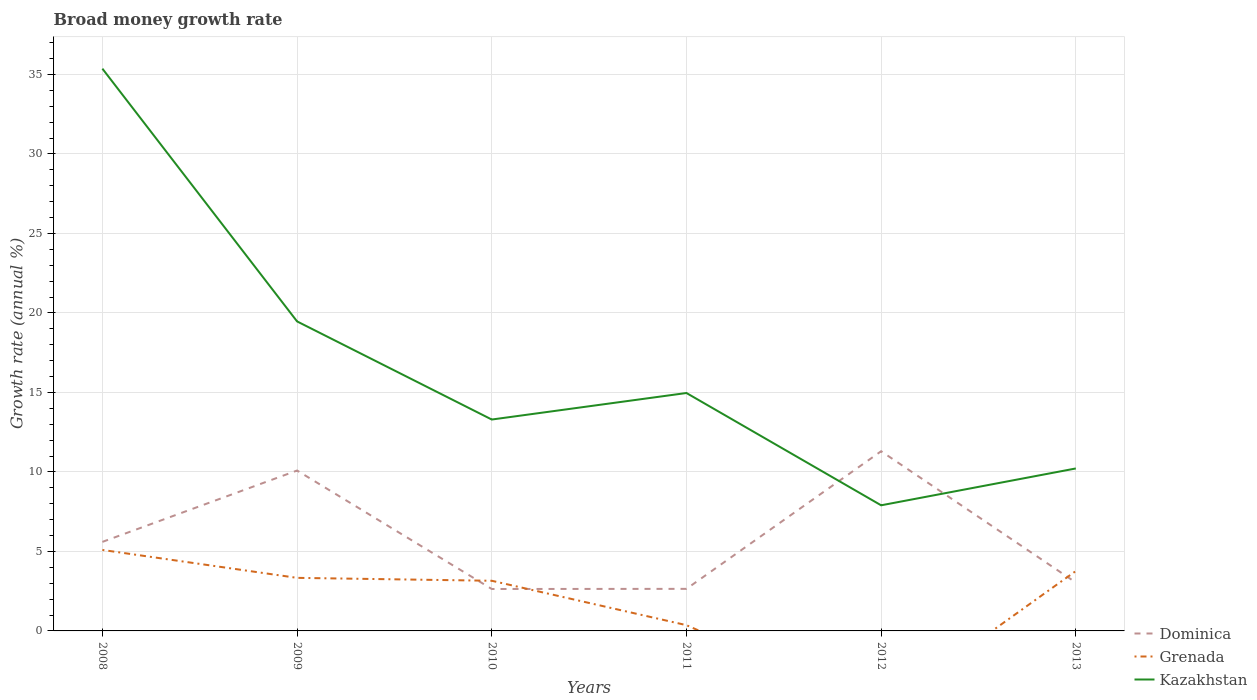Is the number of lines equal to the number of legend labels?
Provide a succinct answer. No. Across all years, what is the maximum growth rate in Dominica?
Give a very brief answer. 2.64. What is the total growth rate in Dominica in the graph?
Offer a very short reply. -0.01. What is the difference between the highest and the second highest growth rate in Grenada?
Offer a very short reply. 5.09. How many lines are there?
Offer a terse response. 3. What is the difference between two consecutive major ticks on the Y-axis?
Your response must be concise. 5. Where does the legend appear in the graph?
Your response must be concise. Bottom right. How many legend labels are there?
Provide a succinct answer. 3. What is the title of the graph?
Offer a very short reply. Broad money growth rate. What is the label or title of the Y-axis?
Keep it short and to the point. Growth rate (annual %). What is the Growth rate (annual %) of Dominica in 2008?
Give a very brief answer. 5.6. What is the Growth rate (annual %) of Grenada in 2008?
Offer a terse response. 5.09. What is the Growth rate (annual %) of Kazakhstan in 2008?
Make the answer very short. 35.37. What is the Growth rate (annual %) of Dominica in 2009?
Your response must be concise. 10.09. What is the Growth rate (annual %) of Grenada in 2009?
Offer a terse response. 3.34. What is the Growth rate (annual %) in Kazakhstan in 2009?
Give a very brief answer. 19.47. What is the Growth rate (annual %) in Dominica in 2010?
Your answer should be very brief. 2.64. What is the Growth rate (annual %) of Grenada in 2010?
Make the answer very short. 3.15. What is the Growth rate (annual %) of Kazakhstan in 2010?
Offer a terse response. 13.3. What is the Growth rate (annual %) of Dominica in 2011?
Your answer should be compact. 2.65. What is the Growth rate (annual %) of Grenada in 2011?
Offer a terse response. 0.36. What is the Growth rate (annual %) of Kazakhstan in 2011?
Keep it short and to the point. 14.96. What is the Growth rate (annual %) in Dominica in 2012?
Make the answer very short. 11.3. What is the Growth rate (annual %) of Kazakhstan in 2012?
Ensure brevity in your answer.  7.9. What is the Growth rate (annual %) in Dominica in 2013?
Offer a terse response. 3.04. What is the Growth rate (annual %) of Grenada in 2013?
Provide a short and direct response. 3.77. What is the Growth rate (annual %) in Kazakhstan in 2013?
Your answer should be very brief. 10.22. Across all years, what is the maximum Growth rate (annual %) of Dominica?
Your answer should be compact. 11.3. Across all years, what is the maximum Growth rate (annual %) in Grenada?
Your response must be concise. 5.09. Across all years, what is the maximum Growth rate (annual %) in Kazakhstan?
Ensure brevity in your answer.  35.37. Across all years, what is the minimum Growth rate (annual %) of Dominica?
Keep it short and to the point. 2.64. Across all years, what is the minimum Growth rate (annual %) in Kazakhstan?
Your answer should be compact. 7.9. What is the total Growth rate (annual %) in Dominica in the graph?
Provide a succinct answer. 35.32. What is the total Growth rate (annual %) of Grenada in the graph?
Provide a short and direct response. 15.71. What is the total Growth rate (annual %) of Kazakhstan in the graph?
Your response must be concise. 101.21. What is the difference between the Growth rate (annual %) in Dominica in 2008 and that in 2009?
Keep it short and to the point. -4.49. What is the difference between the Growth rate (annual %) of Grenada in 2008 and that in 2009?
Your answer should be compact. 1.76. What is the difference between the Growth rate (annual %) in Kazakhstan in 2008 and that in 2009?
Give a very brief answer. 15.9. What is the difference between the Growth rate (annual %) in Dominica in 2008 and that in 2010?
Provide a short and direct response. 2.96. What is the difference between the Growth rate (annual %) in Grenada in 2008 and that in 2010?
Give a very brief answer. 1.94. What is the difference between the Growth rate (annual %) of Kazakhstan in 2008 and that in 2010?
Offer a terse response. 22.07. What is the difference between the Growth rate (annual %) of Dominica in 2008 and that in 2011?
Your answer should be very brief. 2.95. What is the difference between the Growth rate (annual %) in Grenada in 2008 and that in 2011?
Keep it short and to the point. 4.73. What is the difference between the Growth rate (annual %) of Kazakhstan in 2008 and that in 2011?
Your answer should be compact. 20.4. What is the difference between the Growth rate (annual %) of Dominica in 2008 and that in 2012?
Offer a very short reply. -5.7. What is the difference between the Growth rate (annual %) in Kazakhstan in 2008 and that in 2012?
Offer a very short reply. 27.46. What is the difference between the Growth rate (annual %) in Dominica in 2008 and that in 2013?
Provide a short and direct response. 2.56. What is the difference between the Growth rate (annual %) of Grenada in 2008 and that in 2013?
Provide a succinct answer. 1.33. What is the difference between the Growth rate (annual %) in Kazakhstan in 2008 and that in 2013?
Offer a very short reply. 25.15. What is the difference between the Growth rate (annual %) of Dominica in 2009 and that in 2010?
Give a very brief answer. 7.45. What is the difference between the Growth rate (annual %) in Grenada in 2009 and that in 2010?
Ensure brevity in your answer.  0.18. What is the difference between the Growth rate (annual %) of Kazakhstan in 2009 and that in 2010?
Offer a terse response. 6.17. What is the difference between the Growth rate (annual %) of Dominica in 2009 and that in 2011?
Provide a succinct answer. 7.44. What is the difference between the Growth rate (annual %) of Grenada in 2009 and that in 2011?
Offer a terse response. 2.98. What is the difference between the Growth rate (annual %) in Kazakhstan in 2009 and that in 2011?
Make the answer very short. 4.5. What is the difference between the Growth rate (annual %) of Dominica in 2009 and that in 2012?
Give a very brief answer. -1.21. What is the difference between the Growth rate (annual %) of Kazakhstan in 2009 and that in 2012?
Your response must be concise. 11.57. What is the difference between the Growth rate (annual %) in Dominica in 2009 and that in 2013?
Give a very brief answer. 7.05. What is the difference between the Growth rate (annual %) in Grenada in 2009 and that in 2013?
Your answer should be compact. -0.43. What is the difference between the Growth rate (annual %) in Kazakhstan in 2009 and that in 2013?
Make the answer very short. 9.25. What is the difference between the Growth rate (annual %) in Dominica in 2010 and that in 2011?
Your answer should be very brief. -0.01. What is the difference between the Growth rate (annual %) in Grenada in 2010 and that in 2011?
Provide a short and direct response. 2.79. What is the difference between the Growth rate (annual %) of Kazakhstan in 2010 and that in 2011?
Your answer should be compact. -1.67. What is the difference between the Growth rate (annual %) of Dominica in 2010 and that in 2012?
Offer a terse response. -8.66. What is the difference between the Growth rate (annual %) in Kazakhstan in 2010 and that in 2012?
Provide a short and direct response. 5.39. What is the difference between the Growth rate (annual %) of Dominica in 2010 and that in 2013?
Offer a very short reply. -0.41. What is the difference between the Growth rate (annual %) in Grenada in 2010 and that in 2013?
Provide a short and direct response. -0.61. What is the difference between the Growth rate (annual %) in Kazakhstan in 2010 and that in 2013?
Your answer should be compact. 3.08. What is the difference between the Growth rate (annual %) in Dominica in 2011 and that in 2012?
Your answer should be compact. -8.66. What is the difference between the Growth rate (annual %) in Kazakhstan in 2011 and that in 2012?
Make the answer very short. 7.06. What is the difference between the Growth rate (annual %) in Dominica in 2011 and that in 2013?
Offer a very short reply. -0.4. What is the difference between the Growth rate (annual %) in Grenada in 2011 and that in 2013?
Ensure brevity in your answer.  -3.4. What is the difference between the Growth rate (annual %) in Kazakhstan in 2011 and that in 2013?
Give a very brief answer. 4.75. What is the difference between the Growth rate (annual %) in Dominica in 2012 and that in 2013?
Give a very brief answer. 8.26. What is the difference between the Growth rate (annual %) in Kazakhstan in 2012 and that in 2013?
Offer a very short reply. -2.32. What is the difference between the Growth rate (annual %) in Dominica in 2008 and the Growth rate (annual %) in Grenada in 2009?
Make the answer very short. 2.26. What is the difference between the Growth rate (annual %) of Dominica in 2008 and the Growth rate (annual %) of Kazakhstan in 2009?
Offer a terse response. -13.87. What is the difference between the Growth rate (annual %) in Grenada in 2008 and the Growth rate (annual %) in Kazakhstan in 2009?
Provide a succinct answer. -14.37. What is the difference between the Growth rate (annual %) of Dominica in 2008 and the Growth rate (annual %) of Grenada in 2010?
Give a very brief answer. 2.45. What is the difference between the Growth rate (annual %) in Dominica in 2008 and the Growth rate (annual %) in Kazakhstan in 2010?
Provide a succinct answer. -7.7. What is the difference between the Growth rate (annual %) of Grenada in 2008 and the Growth rate (annual %) of Kazakhstan in 2010?
Give a very brief answer. -8.2. What is the difference between the Growth rate (annual %) in Dominica in 2008 and the Growth rate (annual %) in Grenada in 2011?
Your answer should be compact. 5.24. What is the difference between the Growth rate (annual %) of Dominica in 2008 and the Growth rate (annual %) of Kazakhstan in 2011?
Ensure brevity in your answer.  -9.36. What is the difference between the Growth rate (annual %) of Grenada in 2008 and the Growth rate (annual %) of Kazakhstan in 2011?
Offer a very short reply. -9.87. What is the difference between the Growth rate (annual %) in Dominica in 2008 and the Growth rate (annual %) in Kazakhstan in 2012?
Keep it short and to the point. -2.3. What is the difference between the Growth rate (annual %) in Grenada in 2008 and the Growth rate (annual %) in Kazakhstan in 2012?
Offer a very short reply. -2.81. What is the difference between the Growth rate (annual %) of Dominica in 2008 and the Growth rate (annual %) of Grenada in 2013?
Give a very brief answer. 1.83. What is the difference between the Growth rate (annual %) in Dominica in 2008 and the Growth rate (annual %) in Kazakhstan in 2013?
Keep it short and to the point. -4.62. What is the difference between the Growth rate (annual %) of Grenada in 2008 and the Growth rate (annual %) of Kazakhstan in 2013?
Provide a short and direct response. -5.13. What is the difference between the Growth rate (annual %) of Dominica in 2009 and the Growth rate (annual %) of Grenada in 2010?
Your answer should be very brief. 6.93. What is the difference between the Growth rate (annual %) in Dominica in 2009 and the Growth rate (annual %) in Kazakhstan in 2010?
Your answer should be very brief. -3.21. What is the difference between the Growth rate (annual %) of Grenada in 2009 and the Growth rate (annual %) of Kazakhstan in 2010?
Your response must be concise. -9.96. What is the difference between the Growth rate (annual %) of Dominica in 2009 and the Growth rate (annual %) of Grenada in 2011?
Keep it short and to the point. 9.73. What is the difference between the Growth rate (annual %) of Dominica in 2009 and the Growth rate (annual %) of Kazakhstan in 2011?
Offer a very short reply. -4.88. What is the difference between the Growth rate (annual %) of Grenada in 2009 and the Growth rate (annual %) of Kazakhstan in 2011?
Provide a succinct answer. -11.63. What is the difference between the Growth rate (annual %) of Dominica in 2009 and the Growth rate (annual %) of Kazakhstan in 2012?
Provide a succinct answer. 2.19. What is the difference between the Growth rate (annual %) of Grenada in 2009 and the Growth rate (annual %) of Kazakhstan in 2012?
Provide a short and direct response. -4.56. What is the difference between the Growth rate (annual %) in Dominica in 2009 and the Growth rate (annual %) in Grenada in 2013?
Your answer should be very brief. 6.32. What is the difference between the Growth rate (annual %) of Dominica in 2009 and the Growth rate (annual %) of Kazakhstan in 2013?
Your answer should be compact. -0.13. What is the difference between the Growth rate (annual %) in Grenada in 2009 and the Growth rate (annual %) in Kazakhstan in 2013?
Your answer should be compact. -6.88. What is the difference between the Growth rate (annual %) in Dominica in 2010 and the Growth rate (annual %) in Grenada in 2011?
Give a very brief answer. 2.28. What is the difference between the Growth rate (annual %) of Dominica in 2010 and the Growth rate (annual %) of Kazakhstan in 2011?
Give a very brief answer. -12.33. What is the difference between the Growth rate (annual %) of Grenada in 2010 and the Growth rate (annual %) of Kazakhstan in 2011?
Keep it short and to the point. -11.81. What is the difference between the Growth rate (annual %) of Dominica in 2010 and the Growth rate (annual %) of Kazakhstan in 2012?
Your answer should be compact. -5.26. What is the difference between the Growth rate (annual %) in Grenada in 2010 and the Growth rate (annual %) in Kazakhstan in 2012?
Make the answer very short. -4.75. What is the difference between the Growth rate (annual %) of Dominica in 2010 and the Growth rate (annual %) of Grenada in 2013?
Offer a very short reply. -1.13. What is the difference between the Growth rate (annual %) in Dominica in 2010 and the Growth rate (annual %) in Kazakhstan in 2013?
Offer a terse response. -7.58. What is the difference between the Growth rate (annual %) of Grenada in 2010 and the Growth rate (annual %) of Kazakhstan in 2013?
Offer a very short reply. -7.06. What is the difference between the Growth rate (annual %) of Dominica in 2011 and the Growth rate (annual %) of Kazakhstan in 2012?
Your answer should be very brief. -5.26. What is the difference between the Growth rate (annual %) of Grenada in 2011 and the Growth rate (annual %) of Kazakhstan in 2012?
Offer a very short reply. -7.54. What is the difference between the Growth rate (annual %) of Dominica in 2011 and the Growth rate (annual %) of Grenada in 2013?
Your answer should be very brief. -1.12. What is the difference between the Growth rate (annual %) in Dominica in 2011 and the Growth rate (annual %) in Kazakhstan in 2013?
Provide a short and direct response. -7.57. What is the difference between the Growth rate (annual %) in Grenada in 2011 and the Growth rate (annual %) in Kazakhstan in 2013?
Offer a very short reply. -9.86. What is the difference between the Growth rate (annual %) of Dominica in 2012 and the Growth rate (annual %) of Grenada in 2013?
Keep it short and to the point. 7.54. What is the difference between the Growth rate (annual %) in Dominica in 2012 and the Growth rate (annual %) in Kazakhstan in 2013?
Make the answer very short. 1.08. What is the average Growth rate (annual %) in Dominica per year?
Offer a terse response. 5.89. What is the average Growth rate (annual %) of Grenada per year?
Your answer should be very brief. 2.62. What is the average Growth rate (annual %) in Kazakhstan per year?
Give a very brief answer. 16.87. In the year 2008, what is the difference between the Growth rate (annual %) in Dominica and Growth rate (annual %) in Grenada?
Offer a very short reply. 0.51. In the year 2008, what is the difference between the Growth rate (annual %) of Dominica and Growth rate (annual %) of Kazakhstan?
Provide a succinct answer. -29.77. In the year 2008, what is the difference between the Growth rate (annual %) of Grenada and Growth rate (annual %) of Kazakhstan?
Give a very brief answer. -30.27. In the year 2009, what is the difference between the Growth rate (annual %) in Dominica and Growth rate (annual %) in Grenada?
Your answer should be compact. 6.75. In the year 2009, what is the difference between the Growth rate (annual %) of Dominica and Growth rate (annual %) of Kazakhstan?
Give a very brief answer. -9.38. In the year 2009, what is the difference between the Growth rate (annual %) of Grenada and Growth rate (annual %) of Kazakhstan?
Provide a succinct answer. -16.13. In the year 2010, what is the difference between the Growth rate (annual %) of Dominica and Growth rate (annual %) of Grenada?
Give a very brief answer. -0.52. In the year 2010, what is the difference between the Growth rate (annual %) in Dominica and Growth rate (annual %) in Kazakhstan?
Offer a terse response. -10.66. In the year 2010, what is the difference between the Growth rate (annual %) of Grenada and Growth rate (annual %) of Kazakhstan?
Make the answer very short. -10.14. In the year 2011, what is the difference between the Growth rate (annual %) of Dominica and Growth rate (annual %) of Grenada?
Ensure brevity in your answer.  2.28. In the year 2011, what is the difference between the Growth rate (annual %) of Dominica and Growth rate (annual %) of Kazakhstan?
Offer a very short reply. -12.32. In the year 2011, what is the difference between the Growth rate (annual %) of Grenada and Growth rate (annual %) of Kazakhstan?
Your answer should be very brief. -14.6. In the year 2012, what is the difference between the Growth rate (annual %) of Dominica and Growth rate (annual %) of Kazakhstan?
Ensure brevity in your answer.  3.4. In the year 2013, what is the difference between the Growth rate (annual %) in Dominica and Growth rate (annual %) in Grenada?
Your response must be concise. -0.72. In the year 2013, what is the difference between the Growth rate (annual %) of Dominica and Growth rate (annual %) of Kazakhstan?
Your response must be concise. -7.18. In the year 2013, what is the difference between the Growth rate (annual %) of Grenada and Growth rate (annual %) of Kazakhstan?
Give a very brief answer. -6.45. What is the ratio of the Growth rate (annual %) in Dominica in 2008 to that in 2009?
Keep it short and to the point. 0.56. What is the ratio of the Growth rate (annual %) of Grenada in 2008 to that in 2009?
Your answer should be very brief. 1.53. What is the ratio of the Growth rate (annual %) of Kazakhstan in 2008 to that in 2009?
Ensure brevity in your answer.  1.82. What is the ratio of the Growth rate (annual %) in Dominica in 2008 to that in 2010?
Provide a succinct answer. 2.12. What is the ratio of the Growth rate (annual %) in Grenada in 2008 to that in 2010?
Keep it short and to the point. 1.61. What is the ratio of the Growth rate (annual %) in Kazakhstan in 2008 to that in 2010?
Your response must be concise. 2.66. What is the ratio of the Growth rate (annual %) in Dominica in 2008 to that in 2011?
Offer a very short reply. 2.12. What is the ratio of the Growth rate (annual %) in Grenada in 2008 to that in 2011?
Provide a succinct answer. 14.07. What is the ratio of the Growth rate (annual %) in Kazakhstan in 2008 to that in 2011?
Make the answer very short. 2.36. What is the ratio of the Growth rate (annual %) in Dominica in 2008 to that in 2012?
Ensure brevity in your answer.  0.5. What is the ratio of the Growth rate (annual %) in Kazakhstan in 2008 to that in 2012?
Your response must be concise. 4.48. What is the ratio of the Growth rate (annual %) of Dominica in 2008 to that in 2013?
Your answer should be compact. 1.84. What is the ratio of the Growth rate (annual %) of Grenada in 2008 to that in 2013?
Your answer should be compact. 1.35. What is the ratio of the Growth rate (annual %) in Kazakhstan in 2008 to that in 2013?
Ensure brevity in your answer.  3.46. What is the ratio of the Growth rate (annual %) in Dominica in 2009 to that in 2010?
Offer a very short reply. 3.83. What is the ratio of the Growth rate (annual %) of Grenada in 2009 to that in 2010?
Your answer should be very brief. 1.06. What is the ratio of the Growth rate (annual %) of Kazakhstan in 2009 to that in 2010?
Make the answer very short. 1.46. What is the ratio of the Growth rate (annual %) in Dominica in 2009 to that in 2011?
Provide a short and direct response. 3.81. What is the ratio of the Growth rate (annual %) of Grenada in 2009 to that in 2011?
Your answer should be very brief. 9.22. What is the ratio of the Growth rate (annual %) in Kazakhstan in 2009 to that in 2011?
Give a very brief answer. 1.3. What is the ratio of the Growth rate (annual %) in Dominica in 2009 to that in 2012?
Keep it short and to the point. 0.89. What is the ratio of the Growth rate (annual %) in Kazakhstan in 2009 to that in 2012?
Your answer should be very brief. 2.46. What is the ratio of the Growth rate (annual %) in Dominica in 2009 to that in 2013?
Offer a very short reply. 3.32. What is the ratio of the Growth rate (annual %) in Grenada in 2009 to that in 2013?
Your answer should be compact. 0.89. What is the ratio of the Growth rate (annual %) in Kazakhstan in 2009 to that in 2013?
Your answer should be compact. 1.91. What is the ratio of the Growth rate (annual %) in Dominica in 2010 to that in 2011?
Ensure brevity in your answer.  1. What is the ratio of the Growth rate (annual %) in Grenada in 2010 to that in 2011?
Give a very brief answer. 8.72. What is the ratio of the Growth rate (annual %) of Kazakhstan in 2010 to that in 2011?
Offer a terse response. 0.89. What is the ratio of the Growth rate (annual %) of Dominica in 2010 to that in 2012?
Offer a very short reply. 0.23. What is the ratio of the Growth rate (annual %) of Kazakhstan in 2010 to that in 2012?
Provide a succinct answer. 1.68. What is the ratio of the Growth rate (annual %) in Dominica in 2010 to that in 2013?
Offer a very short reply. 0.87. What is the ratio of the Growth rate (annual %) in Grenada in 2010 to that in 2013?
Offer a terse response. 0.84. What is the ratio of the Growth rate (annual %) in Kazakhstan in 2010 to that in 2013?
Your answer should be very brief. 1.3. What is the ratio of the Growth rate (annual %) of Dominica in 2011 to that in 2012?
Offer a terse response. 0.23. What is the ratio of the Growth rate (annual %) in Kazakhstan in 2011 to that in 2012?
Provide a succinct answer. 1.89. What is the ratio of the Growth rate (annual %) in Dominica in 2011 to that in 2013?
Make the answer very short. 0.87. What is the ratio of the Growth rate (annual %) of Grenada in 2011 to that in 2013?
Provide a short and direct response. 0.1. What is the ratio of the Growth rate (annual %) of Kazakhstan in 2011 to that in 2013?
Make the answer very short. 1.46. What is the ratio of the Growth rate (annual %) in Dominica in 2012 to that in 2013?
Keep it short and to the point. 3.71. What is the ratio of the Growth rate (annual %) of Kazakhstan in 2012 to that in 2013?
Provide a short and direct response. 0.77. What is the difference between the highest and the second highest Growth rate (annual %) in Dominica?
Your response must be concise. 1.21. What is the difference between the highest and the second highest Growth rate (annual %) in Grenada?
Provide a short and direct response. 1.33. What is the difference between the highest and the second highest Growth rate (annual %) of Kazakhstan?
Give a very brief answer. 15.9. What is the difference between the highest and the lowest Growth rate (annual %) of Dominica?
Offer a very short reply. 8.66. What is the difference between the highest and the lowest Growth rate (annual %) of Grenada?
Provide a short and direct response. 5.09. What is the difference between the highest and the lowest Growth rate (annual %) in Kazakhstan?
Make the answer very short. 27.46. 